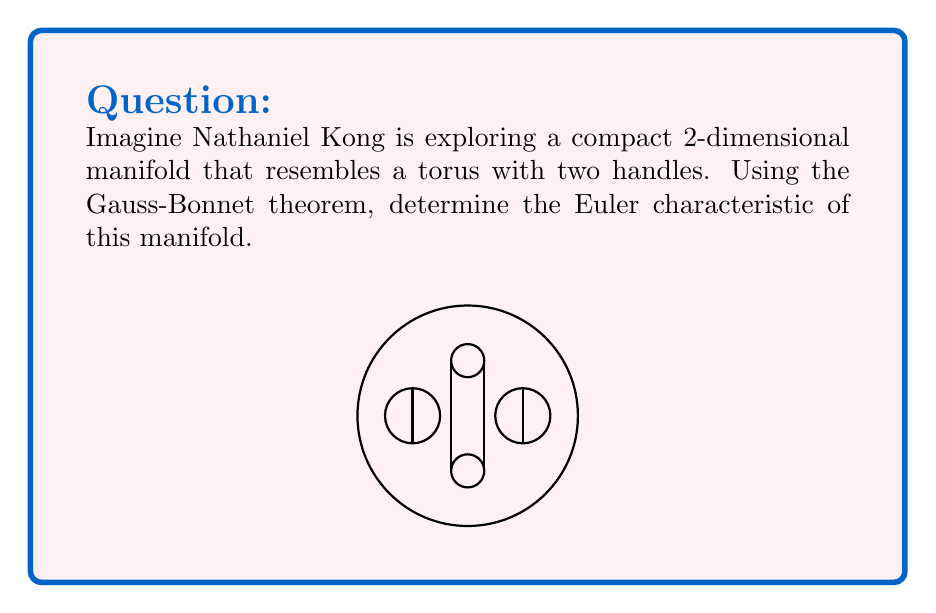Give your solution to this math problem. To solve this problem using the Gauss-Bonnet theorem, we'll follow these steps:

1) Recall the Gauss-Bonnet theorem for a compact 2-dimensional manifold $M$:

   $$\int_M K dA = 2\pi\chi(M)$$

   where $K$ is the Gaussian curvature, $dA$ is the area element, and $\chi(M)$ is the Euler characteristic.

2) For a torus with $g$ handles (genus $g$), the Euler characteristic is given by:

   $$\chi(M) = 2 - 2g$$

3) In this case, we have a torus with 2 handles, so $g = 2$.

4) Substituting into the formula:

   $$\chi(M) = 2 - 2(2) = 2 - 4 = -2$$

5) We can verify this using the Gauss-Bonnet theorem. The total Gaussian curvature of a torus with handles is zero because it can be flattened onto a plane locally everywhere. Therefore:

   $$\int_M K dA = 0 = 2\pi\chi(M)$$

   $$0 = 2\pi\chi(M)$$

   $$\chi(M) = 0$$

6) This confirms our calculation in step 4.

Thus, the Euler characteristic of Nathaniel Kong's manifold (a torus with two handles) is -2.
Answer: $-2$ 